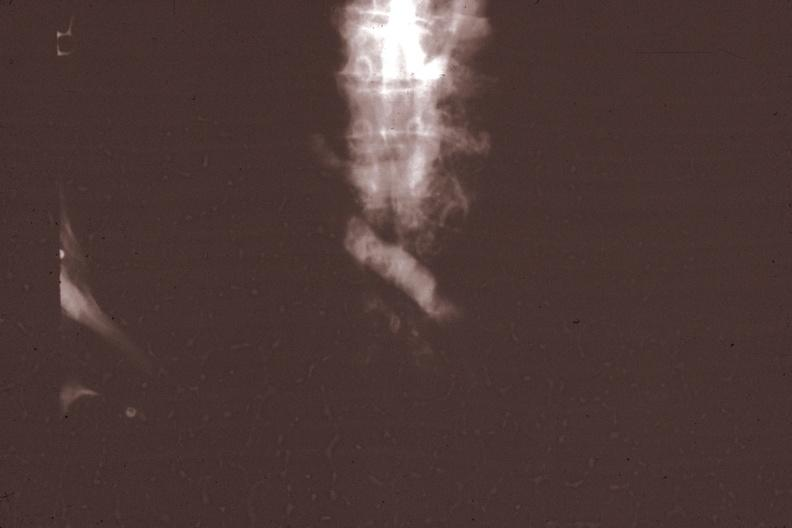what does this image show?
Answer the question using a single word or phrase. X-ray super cava venogram showing obstruction at level of entrance of innominate vein gross photo of tumor in file corresponds 